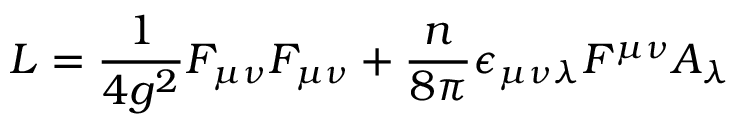<formula> <loc_0><loc_0><loc_500><loc_500>L = \frac { 1 } { 4 g ^ { 2 } } F _ { \mu \nu } F _ { \mu \nu } + \frac { n } { 8 \pi } \epsilon _ { \mu \nu \lambda } F ^ { \mu \nu } A _ { \lambda }</formula> 